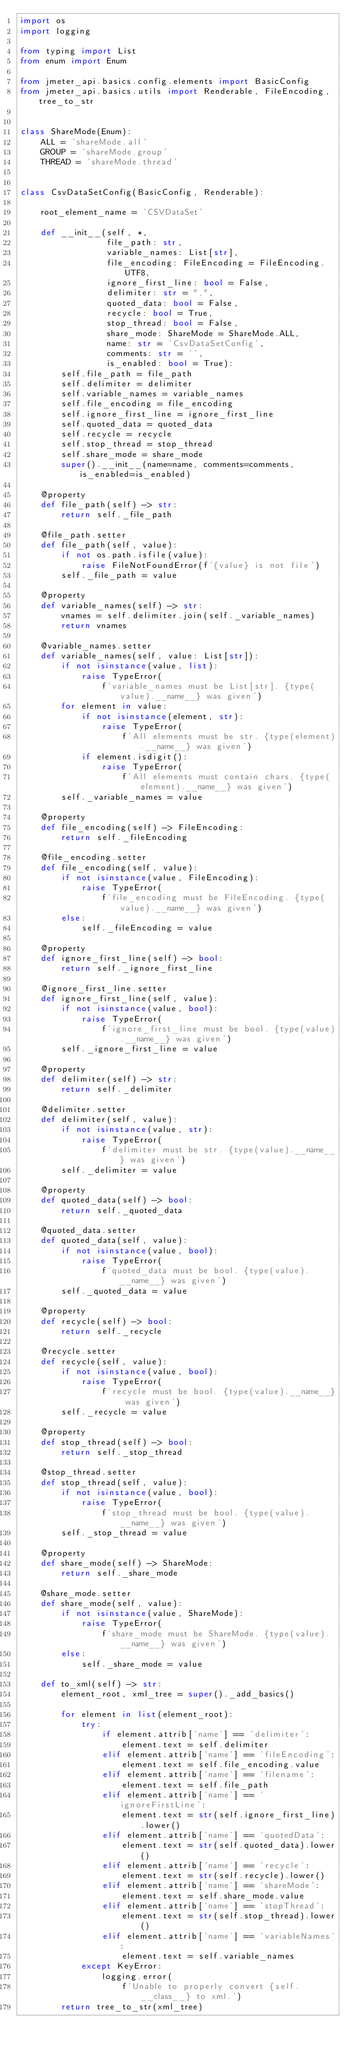<code> <loc_0><loc_0><loc_500><loc_500><_Python_>import os
import logging

from typing import List
from enum import Enum

from jmeter_api.basics.config.elements import BasicConfig
from jmeter_api.basics.utils import Renderable, FileEncoding, tree_to_str


class ShareMode(Enum):
    ALL = 'shareMode.all'
    GROUP = 'shareMode.group'
    THREAD = 'shareMode.thread'


class CsvDataSetConfig(BasicConfig, Renderable):

    root_element_name = 'CSVDataSet'

    def __init__(self, *,
                 file_path: str,
                 variable_names: List[str],
                 file_encoding: FileEncoding = FileEncoding.UTF8,
                 ignore_first_line: bool = False,
                 delimiter: str = ",",
                 quoted_data: bool = False,
                 recycle: bool = True,
                 stop_thread: bool = False,
                 share_mode: ShareMode = ShareMode.ALL,
                 name: str = 'CsvDataSetConfig',
                 comments: str = '',
                 is_enabled: bool = True):
        self.file_path = file_path
        self.delimiter = delimiter
        self.variable_names = variable_names
        self.file_encoding = file_encoding
        self.ignore_first_line = ignore_first_line
        self.quoted_data = quoted_data
        self.recycle = recycle
        self.stop_thread = stop_thread
        self.share_mode = share_mode
        super().__init__(name=name, comments=comments, is_enabled=is_enabled)

    @property
    def file_path(self) -> str:
        return self._file_path

    @file_path.setter
    def file_path(self, value):
        if not os.path.isfile(value):
            raise FileNotFoundError(f'{value} is not file')
        self._file_path = value

    @property
    def variable_names(self) -> str:
        vnames = self.delimiter.join(self._variable_names)
        return vnames

    @variable_names.setter
    def variable_names(self, value: List[str]):
        if not isinstance(value, list):
            raise TypeError(
                f'variable_names must be List[str]. {type(value).__name__} was given')
        for element in value:
            if not isinstance(element, str):
                raise TypeError(
                    f'All elements must be str. {type(element).__name__} was given')
            if element.isdigit():
                raise TypeError(
                    f'All elements must contain chars. {type(element).__name__} was given')
        self._variable_names = value

    @property
    def file_encoding(self) -> FileEncoding:
        return self._fileEncoding

    @file_encoding.setter
    def file_encoding(self, value):
        if not isinstance(value, FileEncoding):
            raise TypeError(
                f'file_encoding must be FileEncoding. {type(value).__name__} was given')
        else:
            self._fileEncoding = value

    @property
    def ignore_first_line(self) -> bool:
        return self._ignore_first_line

    @ignore_first_line.setter
    def ignore_first_line(self, value):
        if not isinstance(value, bool):
            raise TypeError(
                f'ignore_first_line must be bool. {type(value).__name__} was given')
        self._ignore_first_line = value

    @property
    def delimiter(self) -> str:
        return self._delimiter

    @delimiter.setter
    def delimiter(self, value):
        if not isinstance(value, str):
            raise TypeError(
                f'delimiter must be str. {type(value).__name__} was given')
        self._delimiter = value

    @property
    def quoted_data(self) -> bool:
        return self._quoted_data

    @quoted_data.setter
    def quoted_data(self, value):
        if not isinstance(value, bool):
            raise TypeError(
                f'quoted_data must be bool. {type(value).__name__} was given')
        self._quoted_data = value

    @property
    def recycle(self) -> bool:
        return self._recycle

    @recycle.setter
    def recycle(self, value):
        if not isinstance(value, bool):
            raise TypeError(
                f'recycle must be bool. {type(value).__name__} was given')
        self._recycle = value

    @property
    def stop_thread(self) -> bool:
        return self._stop_thread

    @stop_thread.setter
    def stop_thread(self, value):
        if not isinstance(value, bool):
            raise TypeError(
                f'stop_thread must be bool. {type(value).__name__} was given')
        self._stop_thread = value

    @property
    def share_mode(self) -> ShareMode:
        return self._share_mode

    @share_mode.setter
    def share_mode(self, value):
        if not isinstance(value, ShareMode):
            raise TypeError(
                f'share_mode must be ShareMode. {type(value).__name__} was given')
        else:
            self._share_mode = value

    def to_xml(self) -> str:
        element_root, xml_tree = super()._add_basics()

        for element in list(element_root):
            try:
                if element.attrib['name'] == 'delimiter':
                    element.text = self.delimiter
                elif element.attrib['name'] == 'fileEncoding':
                    element.text = self.file_encoding.value
                elif element.attrib['name'] == 'filename':
                    element.text = self.file_path
                elif element.attrib['name'] == 'ignoreFirstLine':
                    element.text = str(self.ignore_first_line).lower()
                elif element.attrib['name'] == 'quotedData':
                    element.text = str(self.quoted_data).lower()
                elif element.attrib['name'] == 'recycle':
                    element.text = str(self.recycle).lower()
                elif element.attrib['name'] == 'shareMode':
                    element.text = self.share_mode.value
                elif element.attrib['name'] == 'stopThread':
                    element.text = str(self.stop_thread).lower()
                elif element.attrib['name'] == 'variableNames':
                    element.text = self.variable_names
            except KeyError:
                logging.error(
                    f'Unable to properly convert {self.__class__} to xml.')
        return tree_to_str(xml_tree)
</code> 